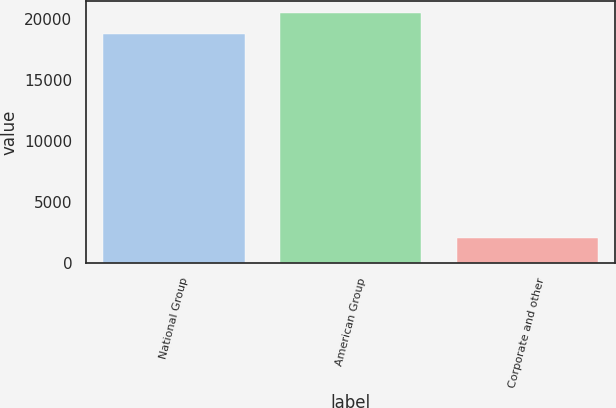Convert chart to OTSL. <chart><loc_0><loc_0><loc_500><loc_500><bar_chart><fcel>National Group<fcel>American Group<fcel>Corporate and other<nl><fcel>18756<fcel>20438.2<fcel>2050<nl></chart> 